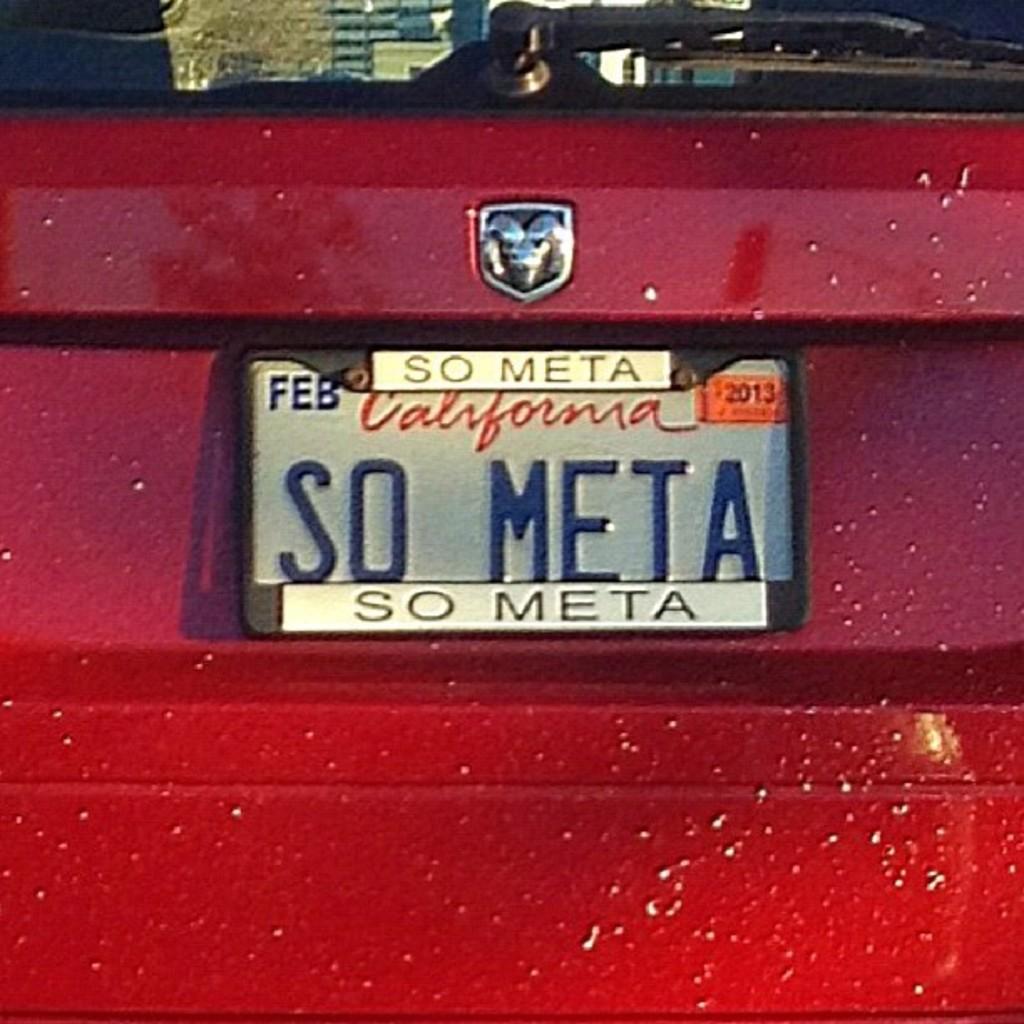What state is this car from?
Provide a succinct answer. California. 